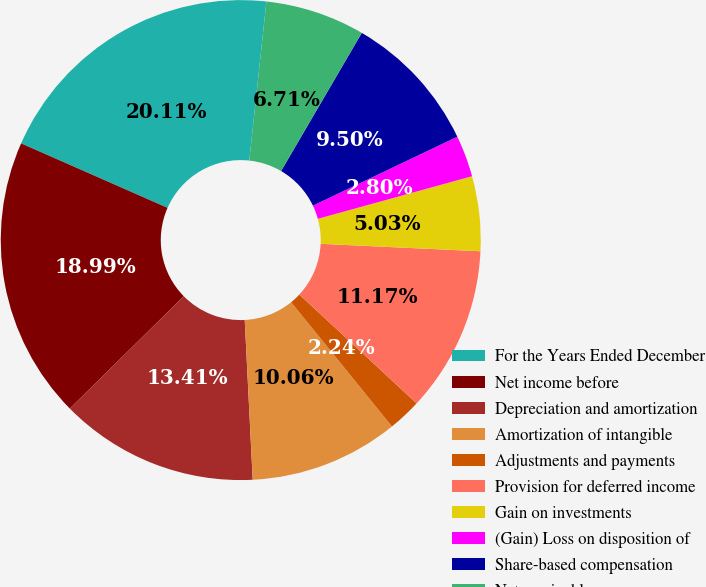Convert chart. <chart><loc_0><loc_0><loc_500><loc_500><pie_chart><fcel>For the Years Ended December<fcel>Net income before<fcel>Depreciation and amortization<fcel>Amortization of intangible<fcel>Adjustments and payments<fcel>Provision for deferred income<fcel>Gain on investments<fcel>(Gain) Loss on disposition of<fcel>Share-based compensation<fcel>Net receivables<nl><fcel>20.11%<fcel>18.99%<fcel>13.41%<fcel>10.06%<fcel>2.24%<fcel>11.17%<fcel>5.03%<fcel>2.8%<fcel>9.5%<fcel>6.71%<nl></chart> 